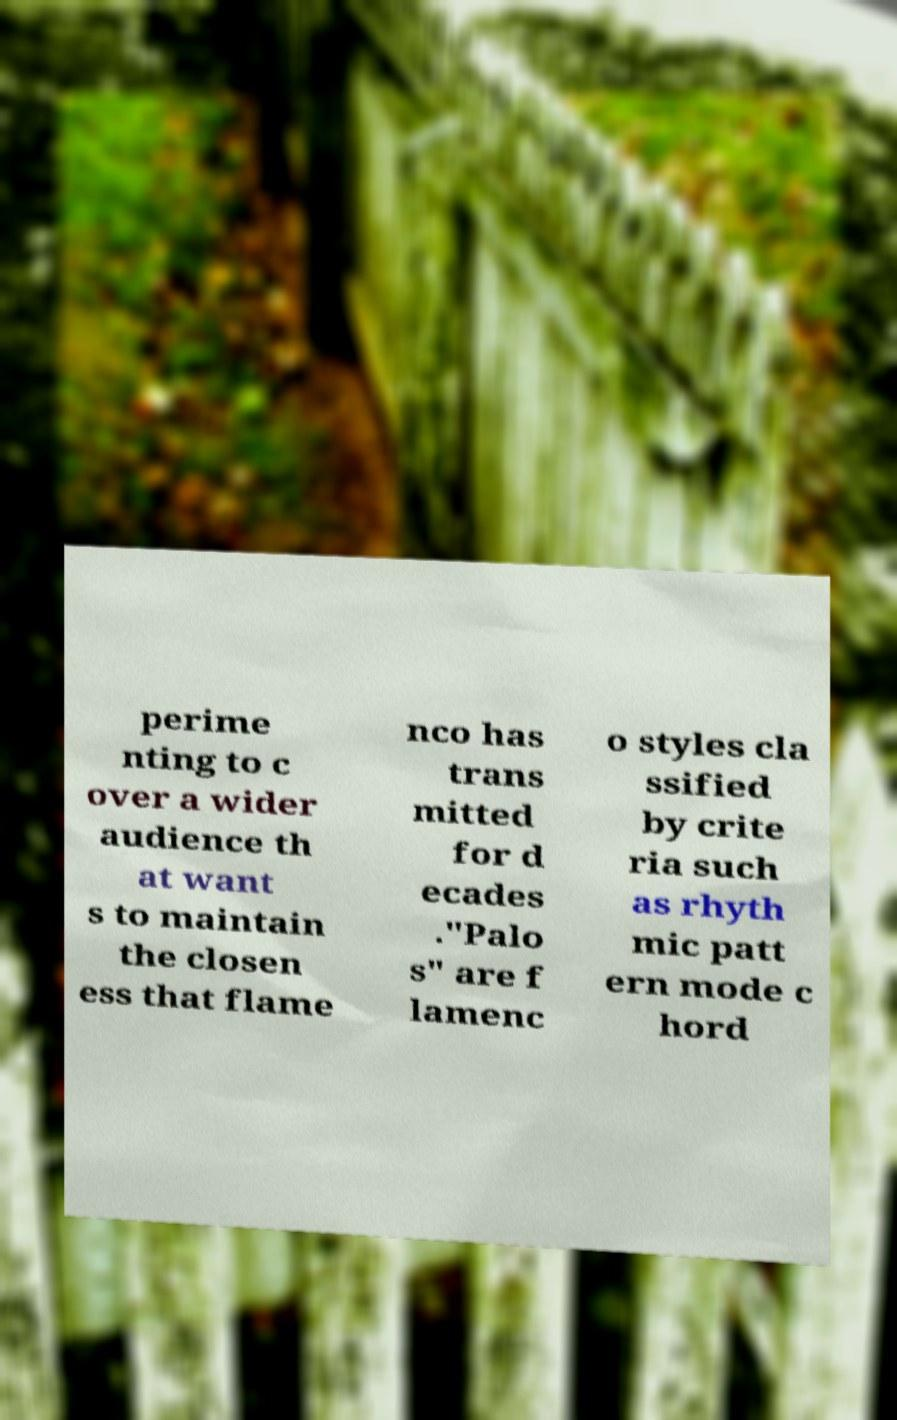What messages or text are displayed in this image? I need them in a readable, typed format. perime nting to c over a wider audience th at want s to maintain the closen ess that flame nco has trans mitted for d ecades ."Palo s" are f lamenc o styles cla ssified by crite ria such as rhyth mic patt ern mode c hord 